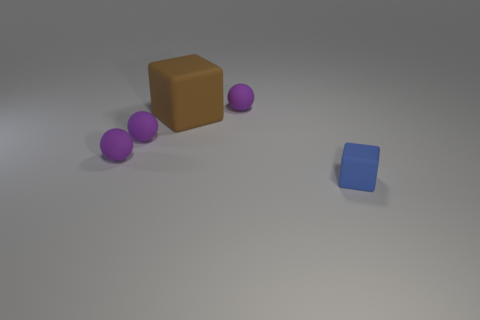Add 3 big matte objects. How many objects exist? 8 Subtract all brown cubes. How many cubes are left? 1 Subtract all spheres. How many objects are left? 2 Subtract all gray cubes. Subtract all cyan cylinders. How many cubes are left? 2 Subtract all purple objects. Subtract all tiny cubes. How many objects are left? 1 Add 3 small blue rubber cubes. How many small blue rubber cubes are left? 4 Add 5 balls. How many balls exist? 8 Subtract 0 red balls. How many objects are left? 5 